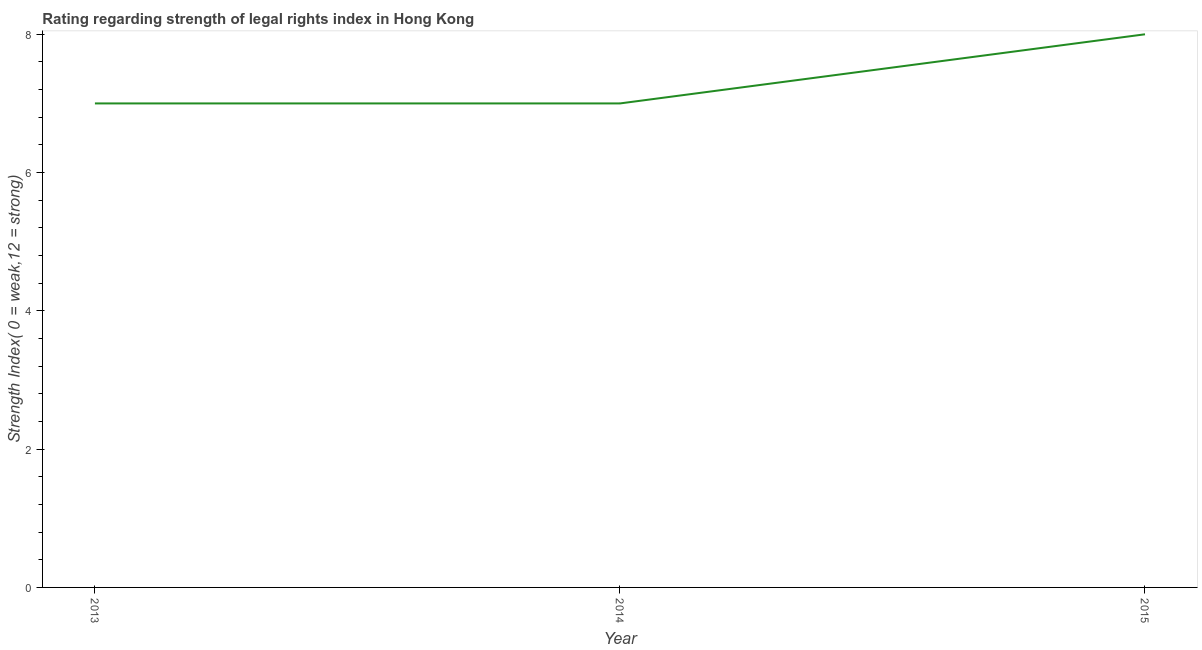What is the strength of legal rights index in 2015?
Provide a short and direct response. 8. Across all years, what is the maximum strength of legal rights index?
Your response must be concise. 8. Across all years, what is the minimum strength of legal rights index?
Offer a terse response. 7. In which year was the strength of legal rights index maximum?
Keep it short and to the point. 2015. What is the sum of the strength of legal rights index?
Your response must be concise. 22. What is the difference between the strength of legal rights index in 2014 and 2015?
Your answer should be compact. -1. What is the average strength of legal rights index per year?
Keep it short and to the point. 7.33. What is the median strength of legal rights index?
Your answer should be very brief. 7. In how many years, is the strength of legal rights index greater than 1.2000000000000002 ?
Offer a very short reply. 3. Do a majority of the years between 2013 and 2014 (inclusive) have strength of legal rights index greater than 1.6 ?
Offer a very short reply. Yes. What is the difference between the highest and the lowest strength of legal rights index?
Your response must be concise. 1. In how many years, is the strength of legal rights index greater than the average strength of legal rights index taken over all years?
Your answer should be compact. 1. What is the difference between two consecutive major ticks on the Y-axis?
Offer a very short reply. 2. What is the title of the graph?
Give a very brief answer. Rating regarding strength of legal rights index in Hong Kong. What is the label or title of the Y-axis?
Ensure brevity in your answer.  Strength Index( 0 = weak,12 = strong). What is the Strength Index( 0 = weak,12 = strong) of 2015?
Give a very brief answer. 8. What is the difference between the Strength Index( 0 = weak,12 = strong) in 2013 and 2015?
Ensure brevity in your answer.  -1. What is the ratio of the Strength Index( 0 = weak,12 = strong) in 2013 to that in 2014?
Offer a terse response. 1. What is the ratio of the Strength Index( 0 = weak,12 = strong) in 2014 to that in 2015?
Provide a succinct answer. 0.88. 